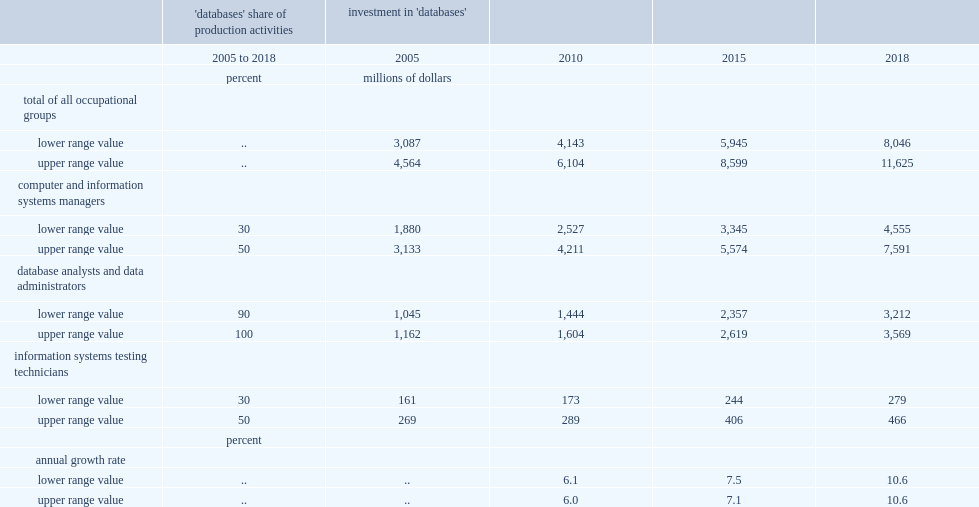In 2018,what were the lower and upper range value of own-account investment in databases(million)? 8046.0 11625.0. About rates of growth in database investment,what were them per annum between 2005 and 2010,2010 to 2015 and 2015 to 2018 respectively? 6.0 7.1 10.6. 